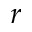Convert formula to latex. <formula><loc_0><loc_0><loc_500><loc_500>r</formula> 